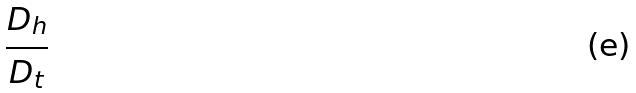<formula> <loc_0><loc_0><loc_500><loc_500>\frac { D _ { h } } { D _ { t } }</formula> 